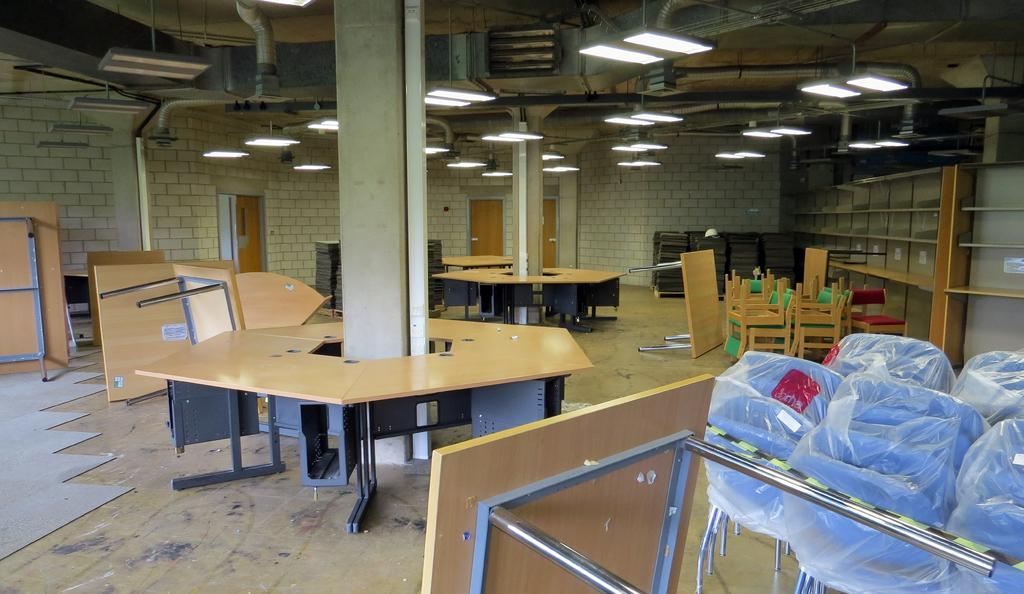What type of furniture is present in the image? There are tables and chairs in the image. What color are the tables and chairs? The tables and chairs are brown in color. What can be seen in the background of the image? There are objects and wooden doors visible in the background of the image. What is used for illumination in the image? There are lights visible in the image. What architectural feature is present in the image? There are pillars in the image. What arithmetic problem is being solved on the table in the image? There is no arithmetic problem visible in the image; it only shows tables, chairs, and other elements. What type of substance is being stored in the wooden doors in the image? There is no substance being stored in the wooden doors in the image; they are simply part of the background. 